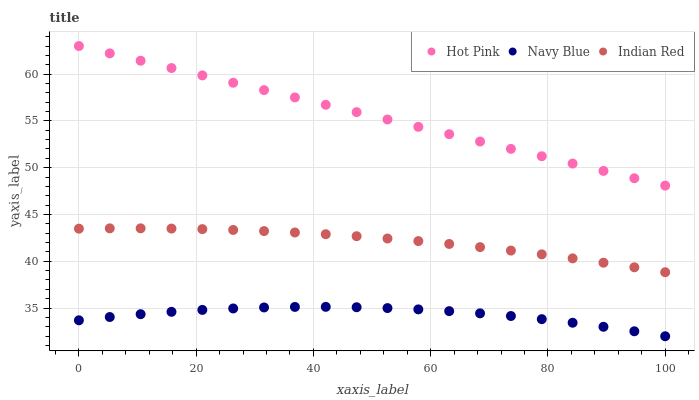Does Navy Blue have the minimum area under the curve?
Answer yes or no. Yes. Does Hot Pink have the maximum area under the curve?
Answer yes or no. Yes. Does Indian Red have the minimum area under the curve?
Answer yes or no. No. Does Indian Red have the maximum area under the curve?
Answer yes or no. No. Is Hot Pink the smoothest?
Answer yes or no. Yes. Is Navy Blue the roughest?
Answer yes or no. Yes. Is Indian Red the smoothest?
Answer yes or no. No. Is Indian Red the roughest?
Answer yes or no. No. Does Navy Blue have the lowest value?
Answer yes or no. Yes. Does Indian Red have the lowest value?
Answer yes or no. No. Does Hot Pink have the highest value?
Answer yes or no. Yes. Does Indian Red have the highest value?
Answer yes or no. No. Is Navy Blue less than Hot Pink?
Answer yes or no. Yes. Is Hot Pink greater than Navy Blue?
Answer yes or no. Yes. Does Navy Blue intersect Hot Pink?
Answer yes or no. No. 